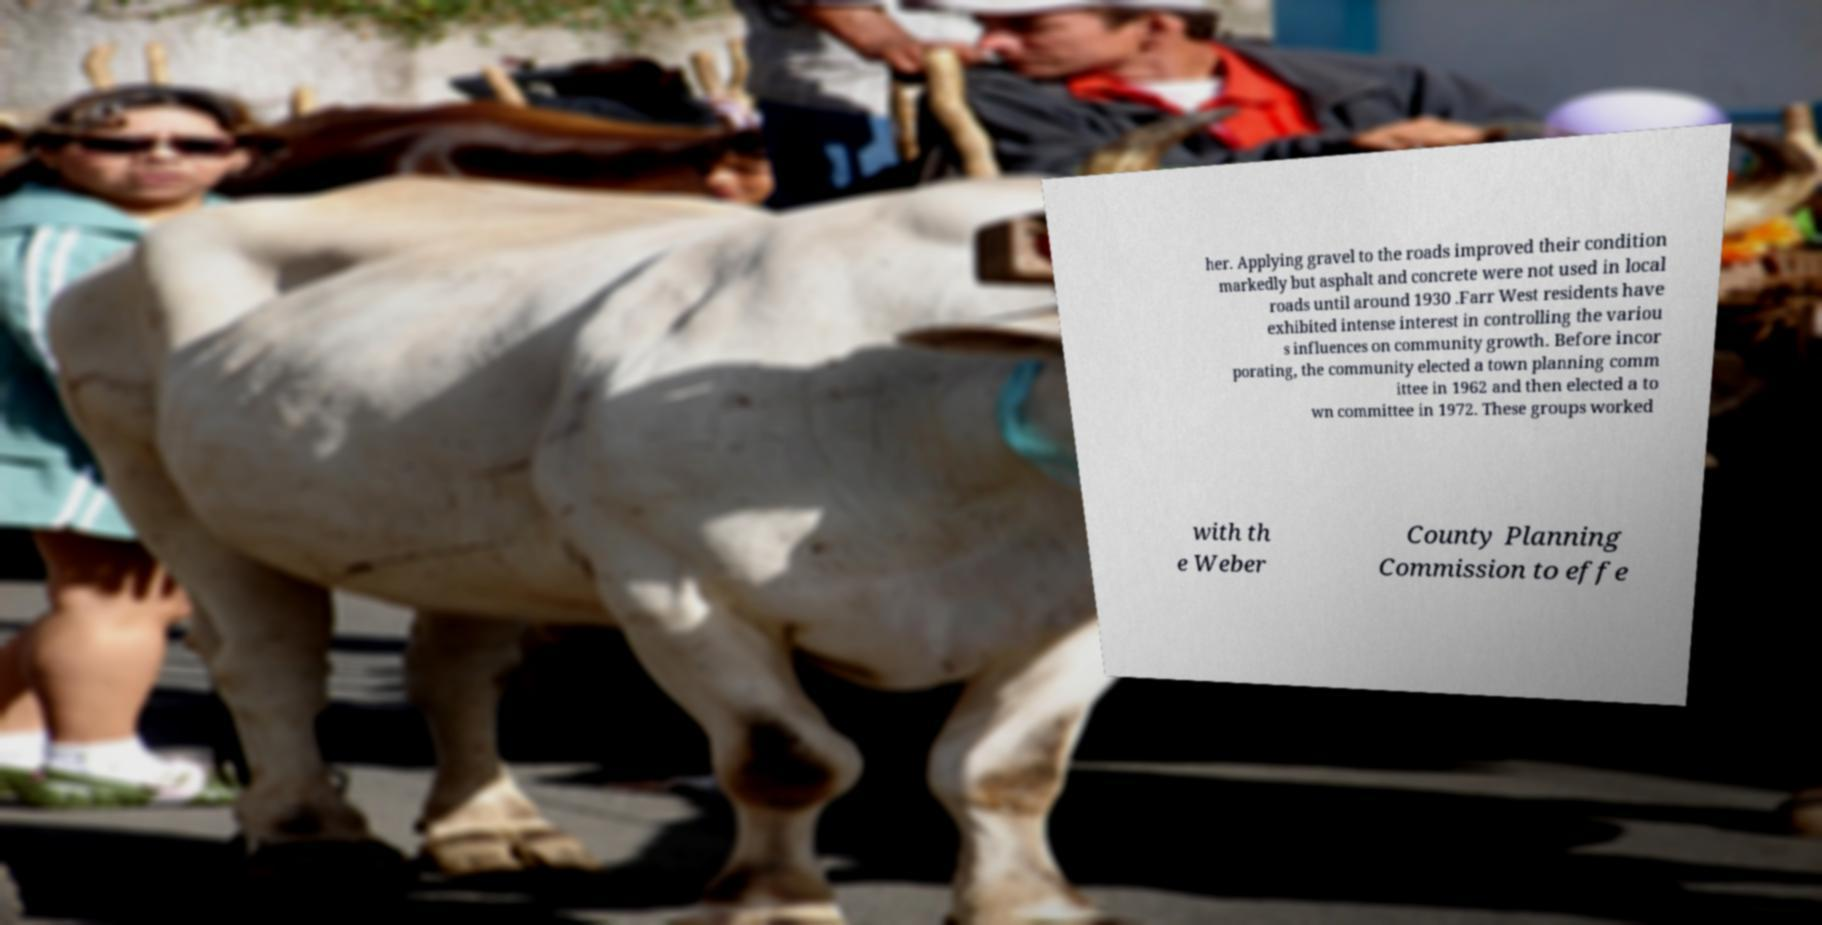Can you accurately transcribe the text from the provided image for me? her. Applying gravel to the roads improved their condition markedly but asphalt and concrete were not used in local roads until around 1930 .Farr West residents have exhibited intense interest in controlling the variou s influences on community growth. Before incor porating, the community elected a town planning comm ittee in 1962 and then elected a to wn committee in 1972. These groups worked with th e Weber County Planning Commission to effe 